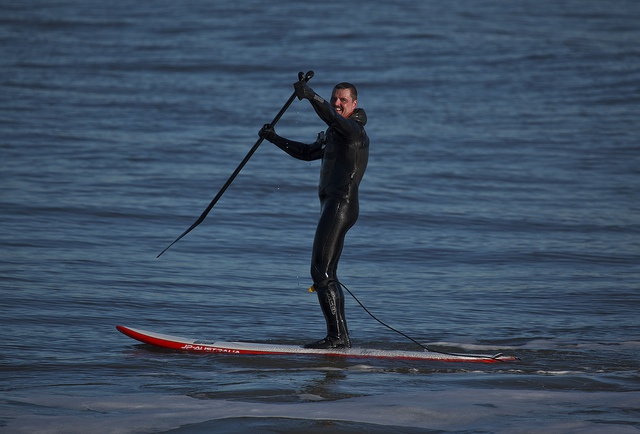Describe the objects in this image and their specific colors. I can see people in darkblue, black, gray, and blue tones and surfboard in darkblue, black, darkgray, gray, and maroon tones in this image. 